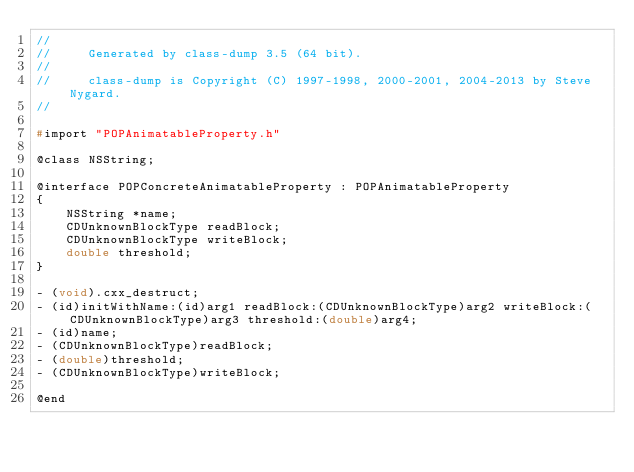<code> <loc_0><loc_0><loc_500><loc_500><_C_>//
//     Generated by class-dump 3.5 (64 bit).
//
//     class-dump is Copyright (C) 1997-1998, 2000-2001, 2004-2013 by Steve Nygard.
//

#import "POPAnimatableProperty.h"

@class NSString;

@interface POPConcreteAnimatableProperty : POPAnimatableProperty
{
    NSString *name;
    CDUnknownBlockType readBlock;
    CDUnknownBlockType writeBlock;
    double threshold;
}

- (void).cxx_destruct;
- (id)initWithName:(id)arg1 readBlock:(CDUnknownBlockType)arg2 writeBlock:(CDUnknownBlockType)arg3 threshold:(double)arg4;
- (id)name;
- (CDUnknownBlockType)readBlock;
- (double)threshold;
- (CDUnknownBlockType)writeBlock;

@end

</code> 